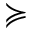Convert formula to latex. <formula><loc_0><loc_0><loc_500><loc_500>\succ c u r l y e q</formula> 